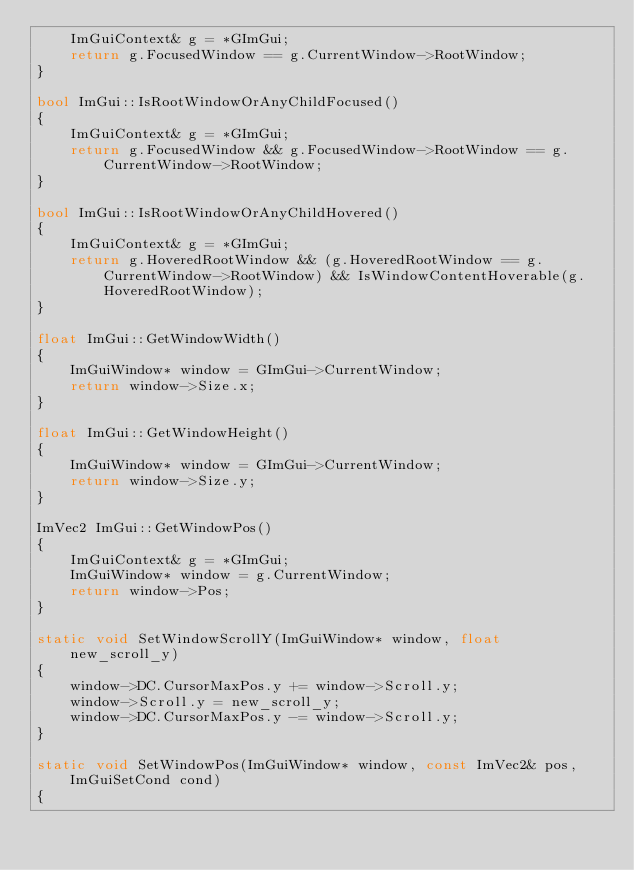<code> <loc_0><loc_0><loc_500><loc_500><_C++_>    ImGuiContext& g = *GImGui;
    return g.FocusedWindow == g.CurrentWindow->RootWindow;
}

bool ImGui::IsRootWindowOrAnyChildFocused()
{
    ImGuiContext& g = *GImGui;
    return g.FocusedWindow && g.FocusedWindow->RootWindow == g.CurrentWindow->RootWindow;
}

bool ImGui::IsRootWindowOrAnyChildHovered()
{
    ImGuiContext& g = *GImGui;
    return g.HoveredRootWindow && (g.HoveredRootWindow == g.CurrentWindow->RootWindow) && IsWindowContentHoverable(g.HoveredRootWindow);
}

float ImGui::GetWindowWidth()
{
    ImGuiWindow* window = GImGui->CurrentWindow;
    return window->Size.x;
}

float ImGui::GetWindowHeight()
{
    ImGuiWindow* window = GImGui->CurrentWindow;
    return window->Size.y;
}

ImVec2 ImGui::GetWindowPos()
{
    ImGuiContext& g = *GImGui;
    ImGuiWindow* window = g.CurrentWindow;
    return window->Pos;
}

static void SetWindowScrollY(ImGuiWindow* window, float new_scroll_y)
{
    window->DC.CursorMaxPos.y += window->Scroll.y;
    window->Scroll.y = new_scroll_y;
    window->DC.CursorMaxPos.y -= window->Scroll.y;
}

static void SetWindowPos(ImGuiWindow* window, const ImVec2& pos, ImGuiSetCond cond)
{</code> 